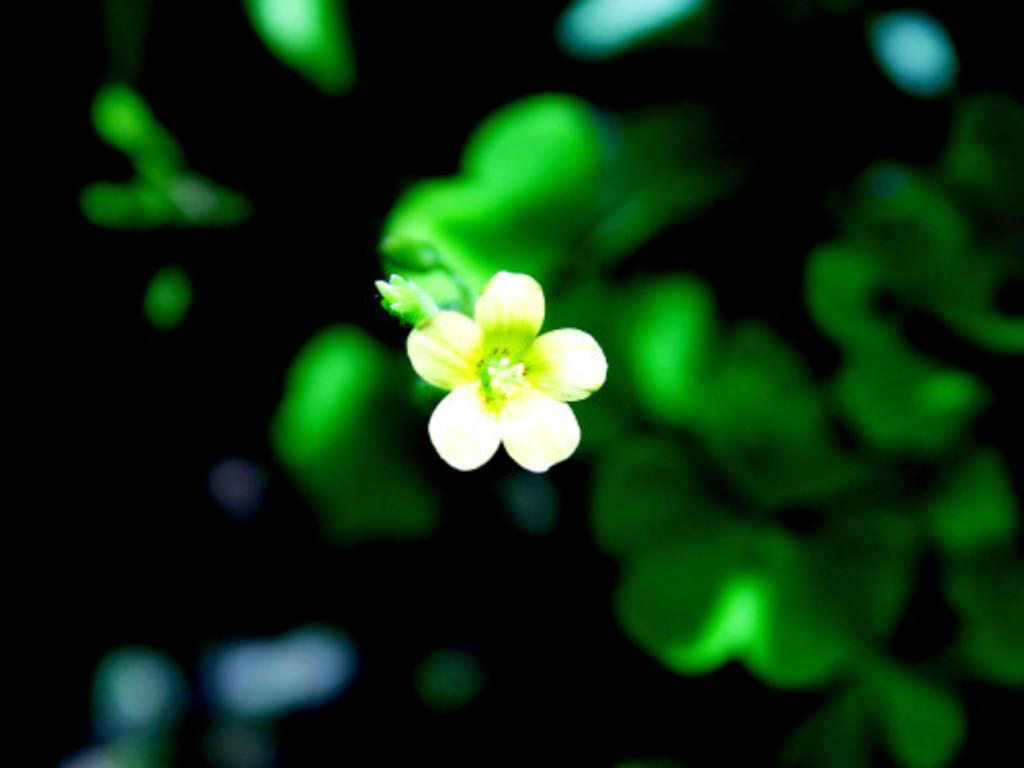What is the main subject of the image? There is a flower in the image. What else can be seen in the background of the image? There are leaves visible in the background of the image. How would you describe the quality of the image? The image is blurry. How many wishes can be granted by the cent in the image? There is no cent present in the image, so it cannot grant any wishes. 